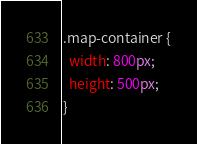Convert code to text. <code><loc_0><loc_0><loc_500><loc_500><_CSS_>.map-container {
  width: 800px;
  height: 500px;
}</code> 